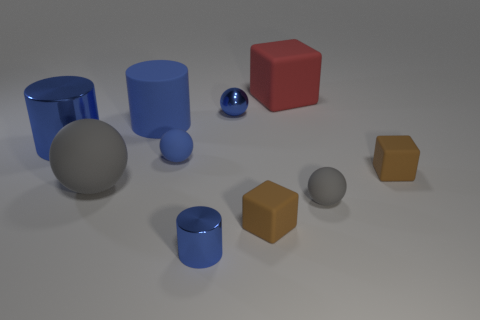Is there a blue metallic sphere of the same size as the red object?
Your answer should be very brief. No. There is a big object that is the same color as the large metallic cylinder; what is its shape?
Your answer should be very brief. Cylinder. What number of gray rubber objects have the same size as the red rubber block?
Ensure brevity in your answer.  1. Is the size of the metallic thing left of the large matte cylinder the same as the blue rubber thing behind the big shiny cylinder?
Offer a very short reply. Yes. How many things are either large yellow matte spheres or rubber balls that are right of the small cylinder?
Offer a terse response. 1. The big shiny cylinder is what color?
Keep it short and to the point. Blue. What is the blue ball that is right of the small thing that is in front of the tiny brown matte cube that is to the left of the red thing made of?
Make the answer very short. Metal. The other gray thing that is made of the same material as the large gray thing is what size?
Offer a very short reply. Small. Are there any big matte cylinders of the same color as the large matte cube?
Offer a terse response. No. Does the red thing have the same size as the gray rubber ball to the left of the blue metallic sphere?
Make the answer very short. Yes. 